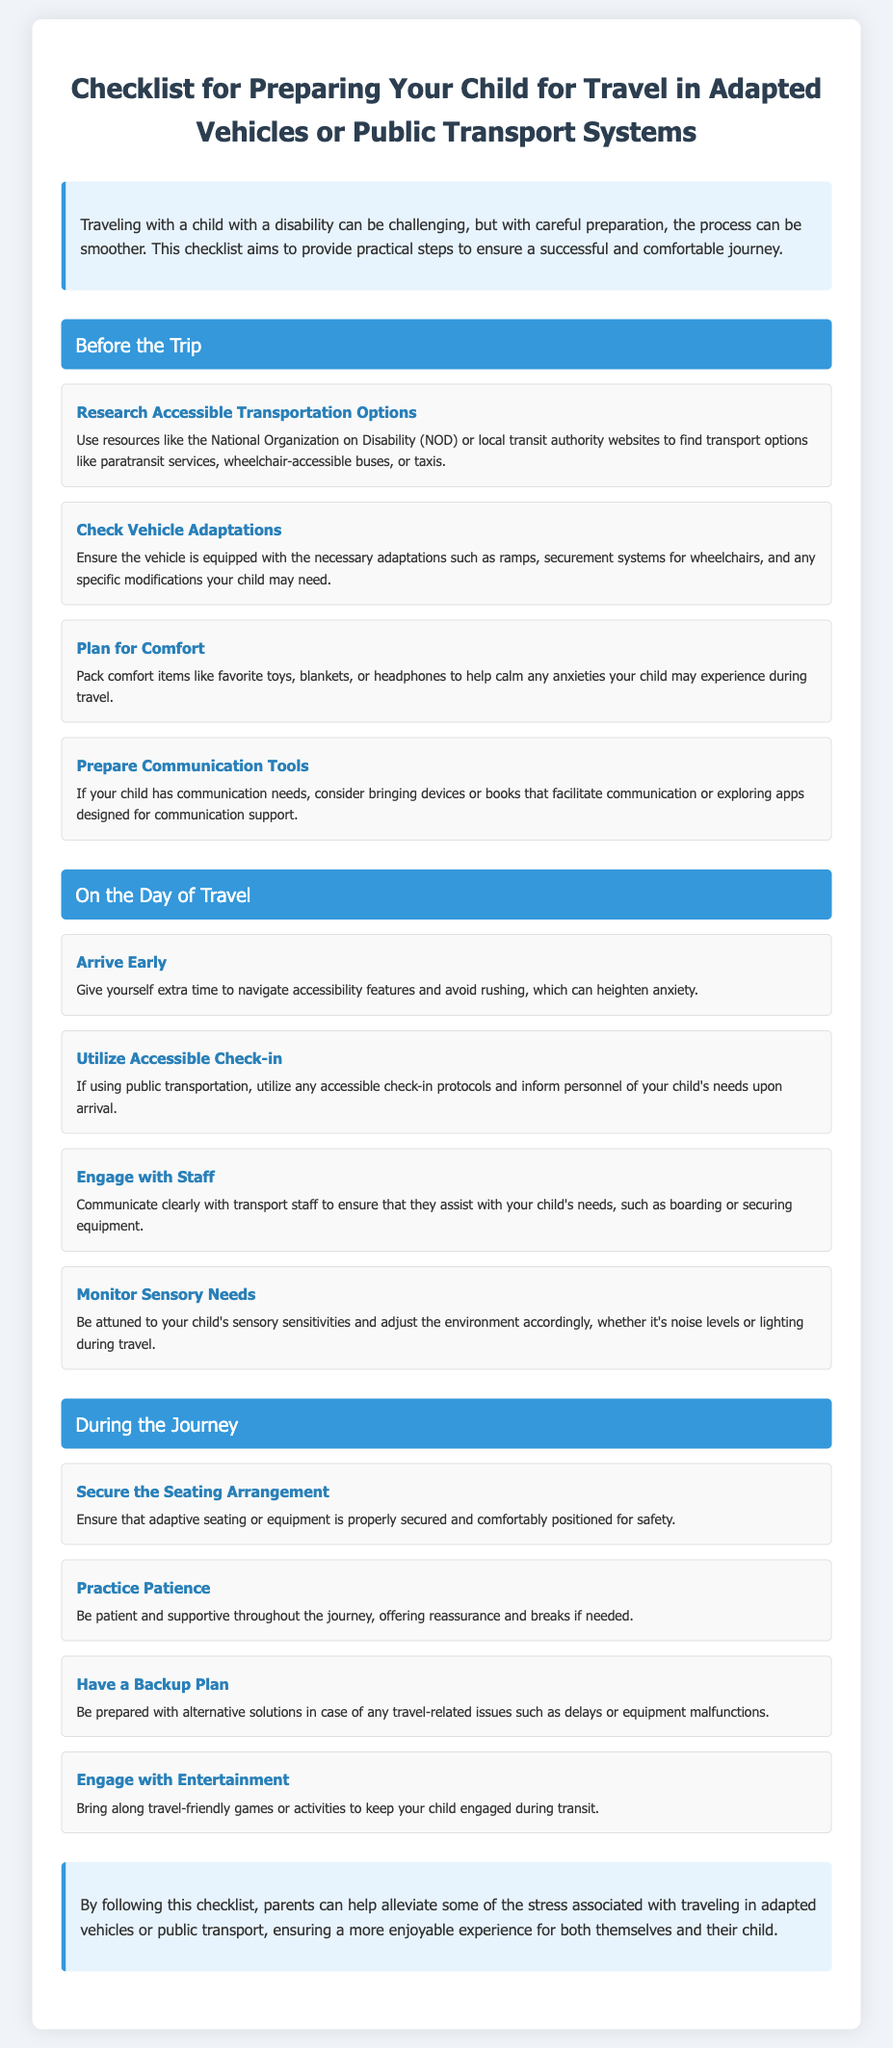What is the title of the document? The title of the document is provided at the beginning under the main heading.
Answer: Checklist for Preparing Your Child for Travel in Adapted Vehicles or Public Transport Systems What is one resource to research accessible transportation options? The document mentions resources such as "the National Organization on Disability (NOD)."
Answer: National Organization on Disability What is a recommended comfort item to pack? The document suggests packing items to help calm anxieties, such as "favorite toys."
Answer: favorite toys What should you do on the day of travel? The checklist advises to "arrive early" to give extra time for accessibility features.
Answer: arrive early How can you engage with transport staff? It is suggested to "communicate clearly with transport staff" about your child's needs.
Answer: communicate clearly What should you monitor during the journey? The document states you should "monitor sensory needs" during the travel process.
Answer: monitor sensory needs What is one of the tasks under "During the Journey"? One of the tasks listed is to "secure the seating arrangement."
Answer: secure the seating arrangement What type of checklist is this document categorized as? The document is categorized as a checklist aimed at preparing for travel with children who have disabilities.
Answer: checklist What is the purpose of this checklist? The purpose is to "alleviate some of the stress associated with traveling."
Answer: alleviate stress 